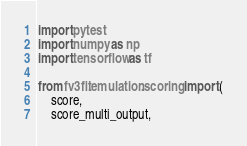Convert code to text. <code><loc_0><loc_0><loc_500><loc_500><_Python_>import pytest
import numpy as np
import tensorflow as tf

from fv3fit.emulation.scoring import (
    score,
    score_multi_output,</code> 